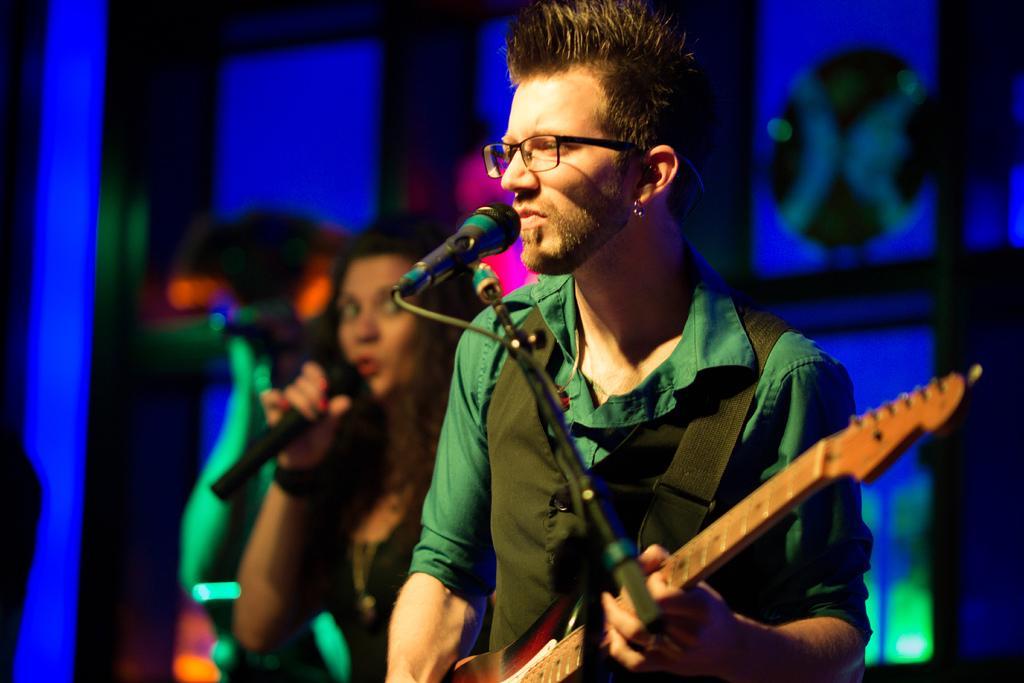In one or two sentences, can you explain what this image depicts? In this picture there is a man who is wearing spectacles, t-shirt and jacket. He is standing near to the mic and holding a guitar. Beside him we can see women who is singing. In the background we can see designed cloth. 